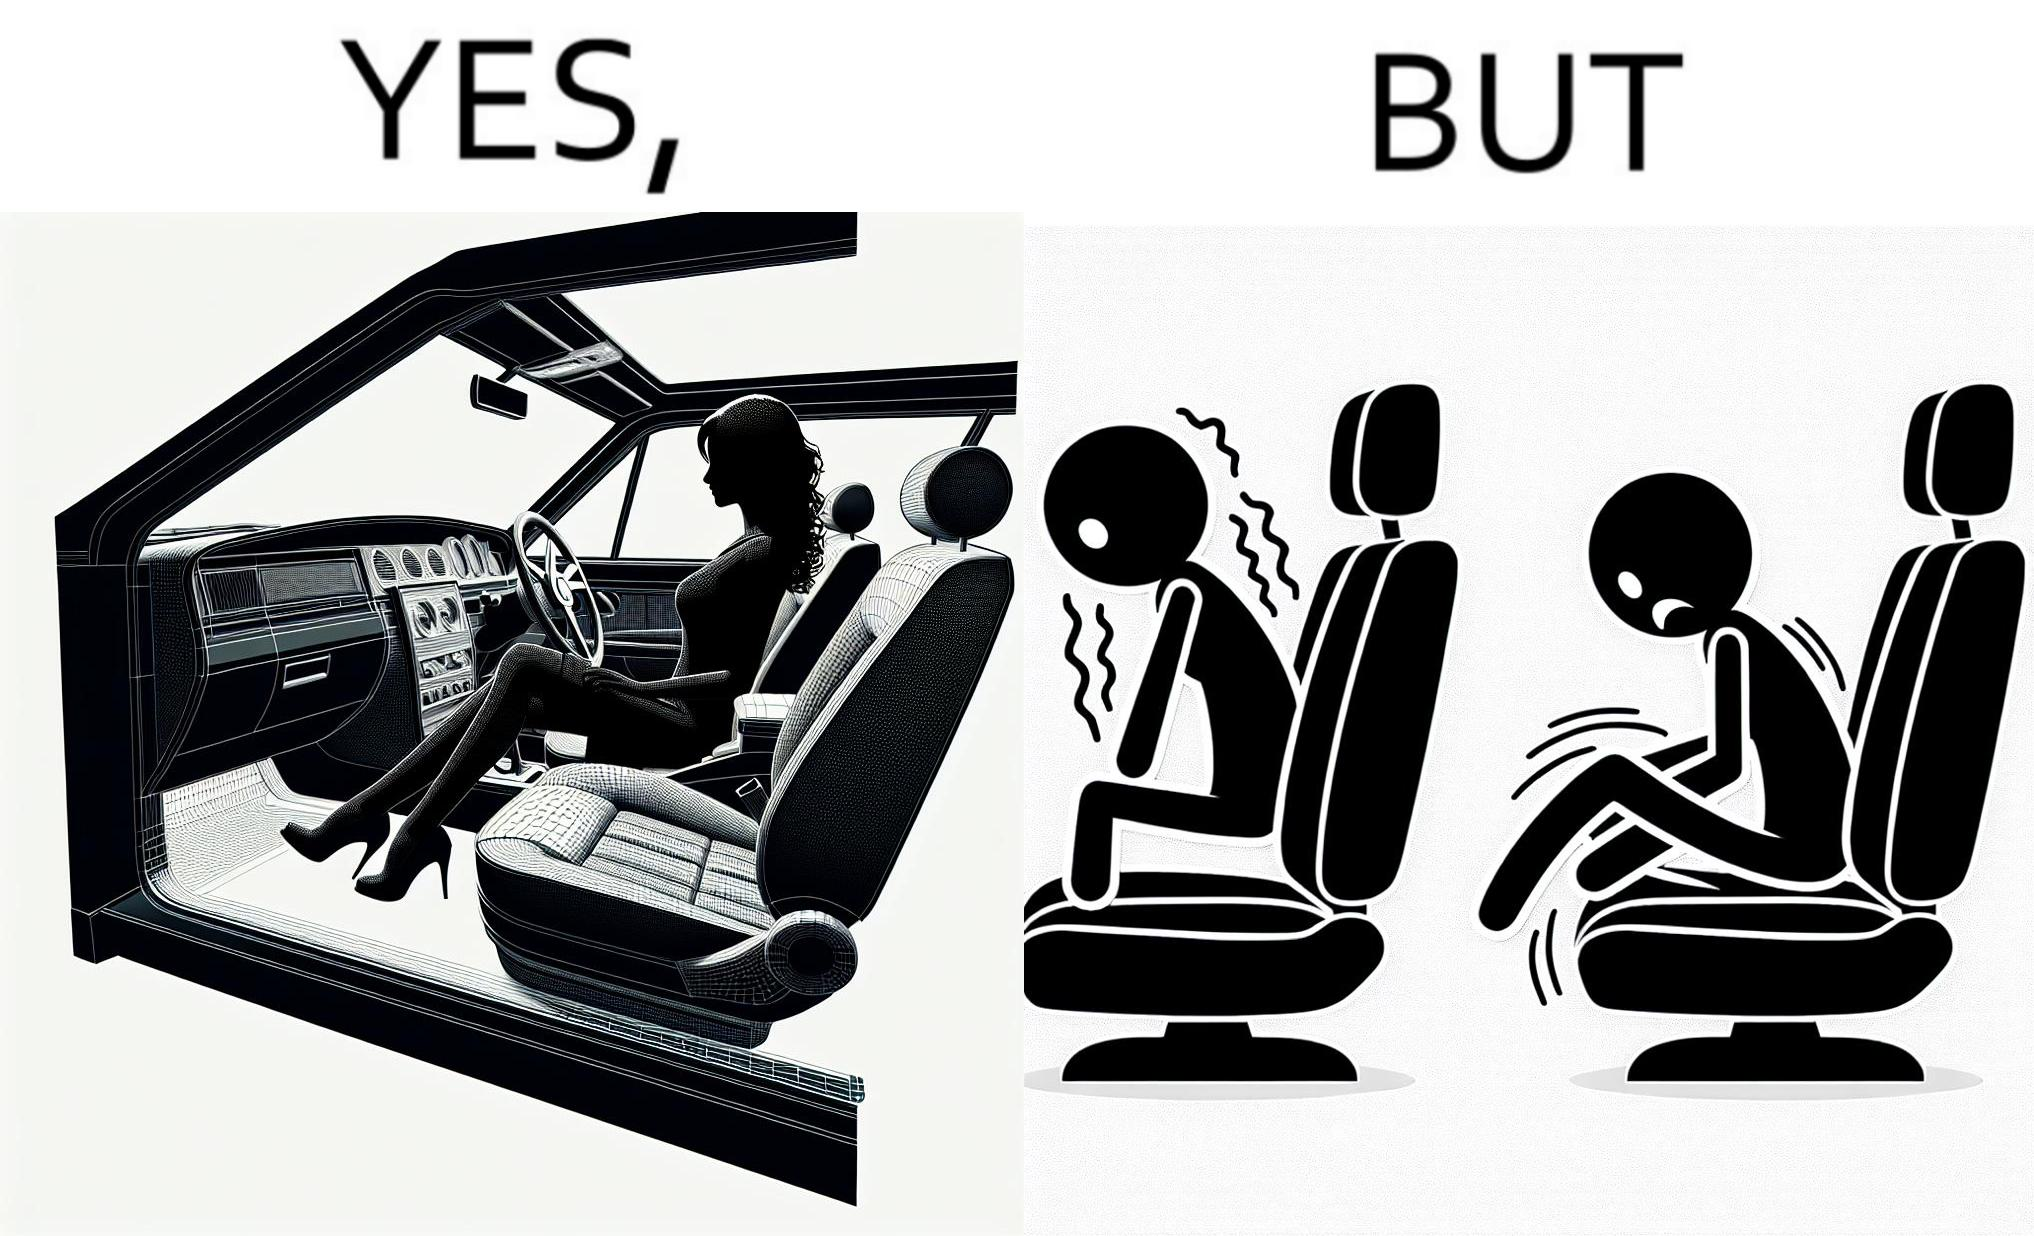Does this image contain satire or humor? Yes, this image is satirical. 